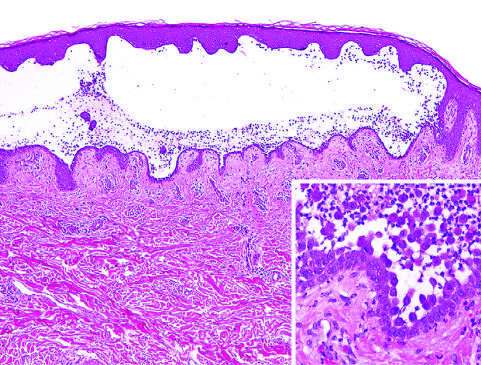how are rounded, dissociated keratinocytes?
Answer the question using a single word or phrase. Suprabasal intraepidermal blister which rounded 